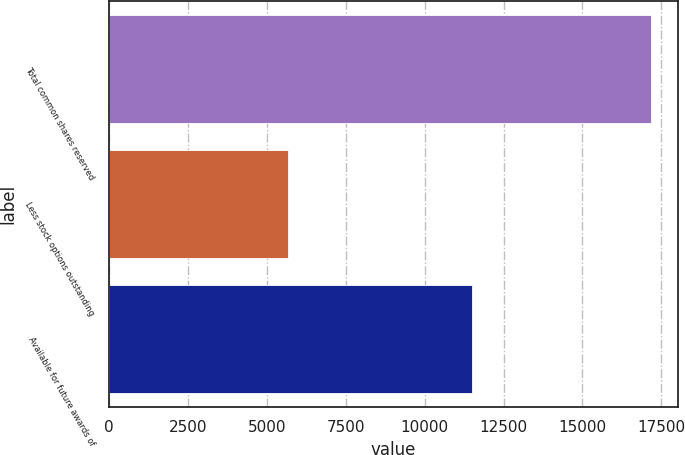Convert chart. <chart><loc_0><loc_0><loc_500><loc_500><bar_chart><fcel>Total common shares reserved<fcel>Less stock options outstanding<fcel>Available for future awards of<nl><fcel>17178<fcel>5671<fcel>11507<nl></chart> 